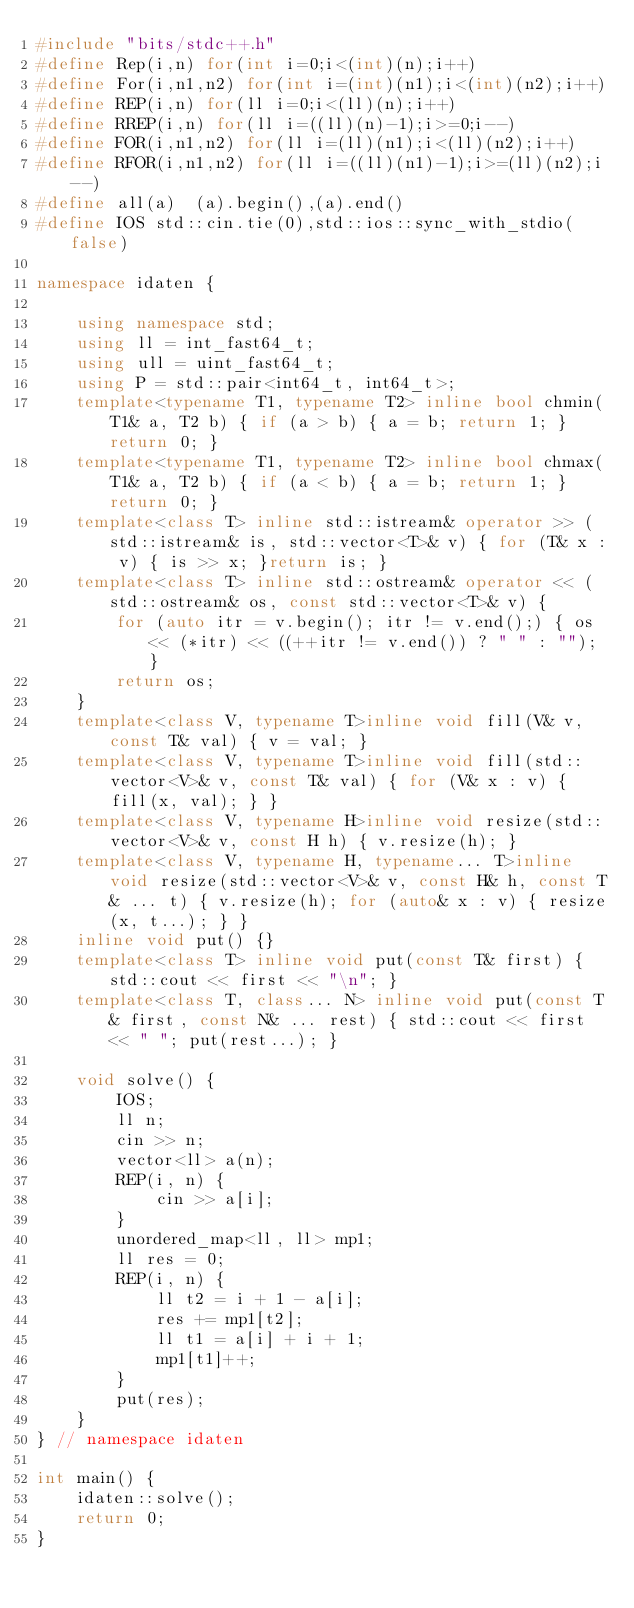Convert code to text. <code><loc_0><loc_0><loc_500><loc_500><_C++_>#include "bits/stdc++.h"
#define Rep(i,n) for(int i=0;i<(int)(n);i++)
#define For(i,n1,n2) for(int i=(int)(n1);i<(int)(n2);i++)
#define REP(i,n) for(ll i=0;i<(ll)(n);i++)
#define RREP(i,n) for(ll i=((ll)(n)-1);i>=0;i--)
#define FOR(i,n1,n2) for(ll i=(ll)(n1);i<(ll)(n2);i++)
#define RFOR(i,n1,n2) for(ll i=((ll)(n1)-1);i>=(ll)(n2);i--)
#define all(a)  (a).begin(),(a).end()
#define IOS std::cin.tie(0),std::ios::sync_with_stdio(false)

namespace idaten {

	using namespace std;
	using ll = int_fast64_t;
	using ull = uint_fast64_t;
	using P = std::pair<int64_t, int64_t>;
	template<typename T1, typename T2> inline bool chmin(T1& a, T2 b) { if (a > b) { a = b; return 1; }return 0; }
	template<typename T1, typename T2> inline bool chmax(T1& a, T2 b) { if (a < b) { a = b; return 1; }return 0; }
	template<class T> inline std::istream& operator >> (std::istream& is, std::vector<T>& v) { for (T& x : v) { is >> x; }return is; }
	template<class T> inline std::ostream& operator << (std::ostream& os, const std::vector<T>& v) {
		for (auto itr = v.begin(); itr != v.end();) { os << (*itr) << ((++itr != v.end()) ? " " : ""); }
		return os;
	}
	template<class V, typename T>inline void fill(V& v, const T& val) { v = val; }
	template<class V, typename T>inline void fill(std::vector<V>& v, const T& val) { for (V& x : v) { fill(x, val); } }
	template<class V, typename H>inline void resize(std::vector<V>& v, const H h) { v.resize(h); }
	template<class V, typename H, typename... T>inline void resize(std::vector<V>& v, const H& h, const T& ... t) { v.resize(h); for (auto& x : v) { resize(x, t...); } }
	inline void put() {}
	template<class T> inline void put(const T& first) { std::cout << first << "\n"; }
	template<class T, class... N> inline void put(const T& first, const N& ... rest) { std::cout << first << " "; put(rest...); }

	void solve() {
		IOS;
		ll n;
		cin >> n;
		vector<ll> a(n);
		REP(i, n) {
			cin >> a[i];
		}
		unordered_map<ll, ll> mp1;
		ll res = 0;
		REP(i, n) {
			ll t2 = i + 1 - a[i];
			res += mp1[t2];
			ll t1 = a[i] + i + 1;
			mp1[t1]++;
		}
		put(res);
	}
} // namespace idaten

int main() {
	idaten::solve();
	return 0;
}
</code> 